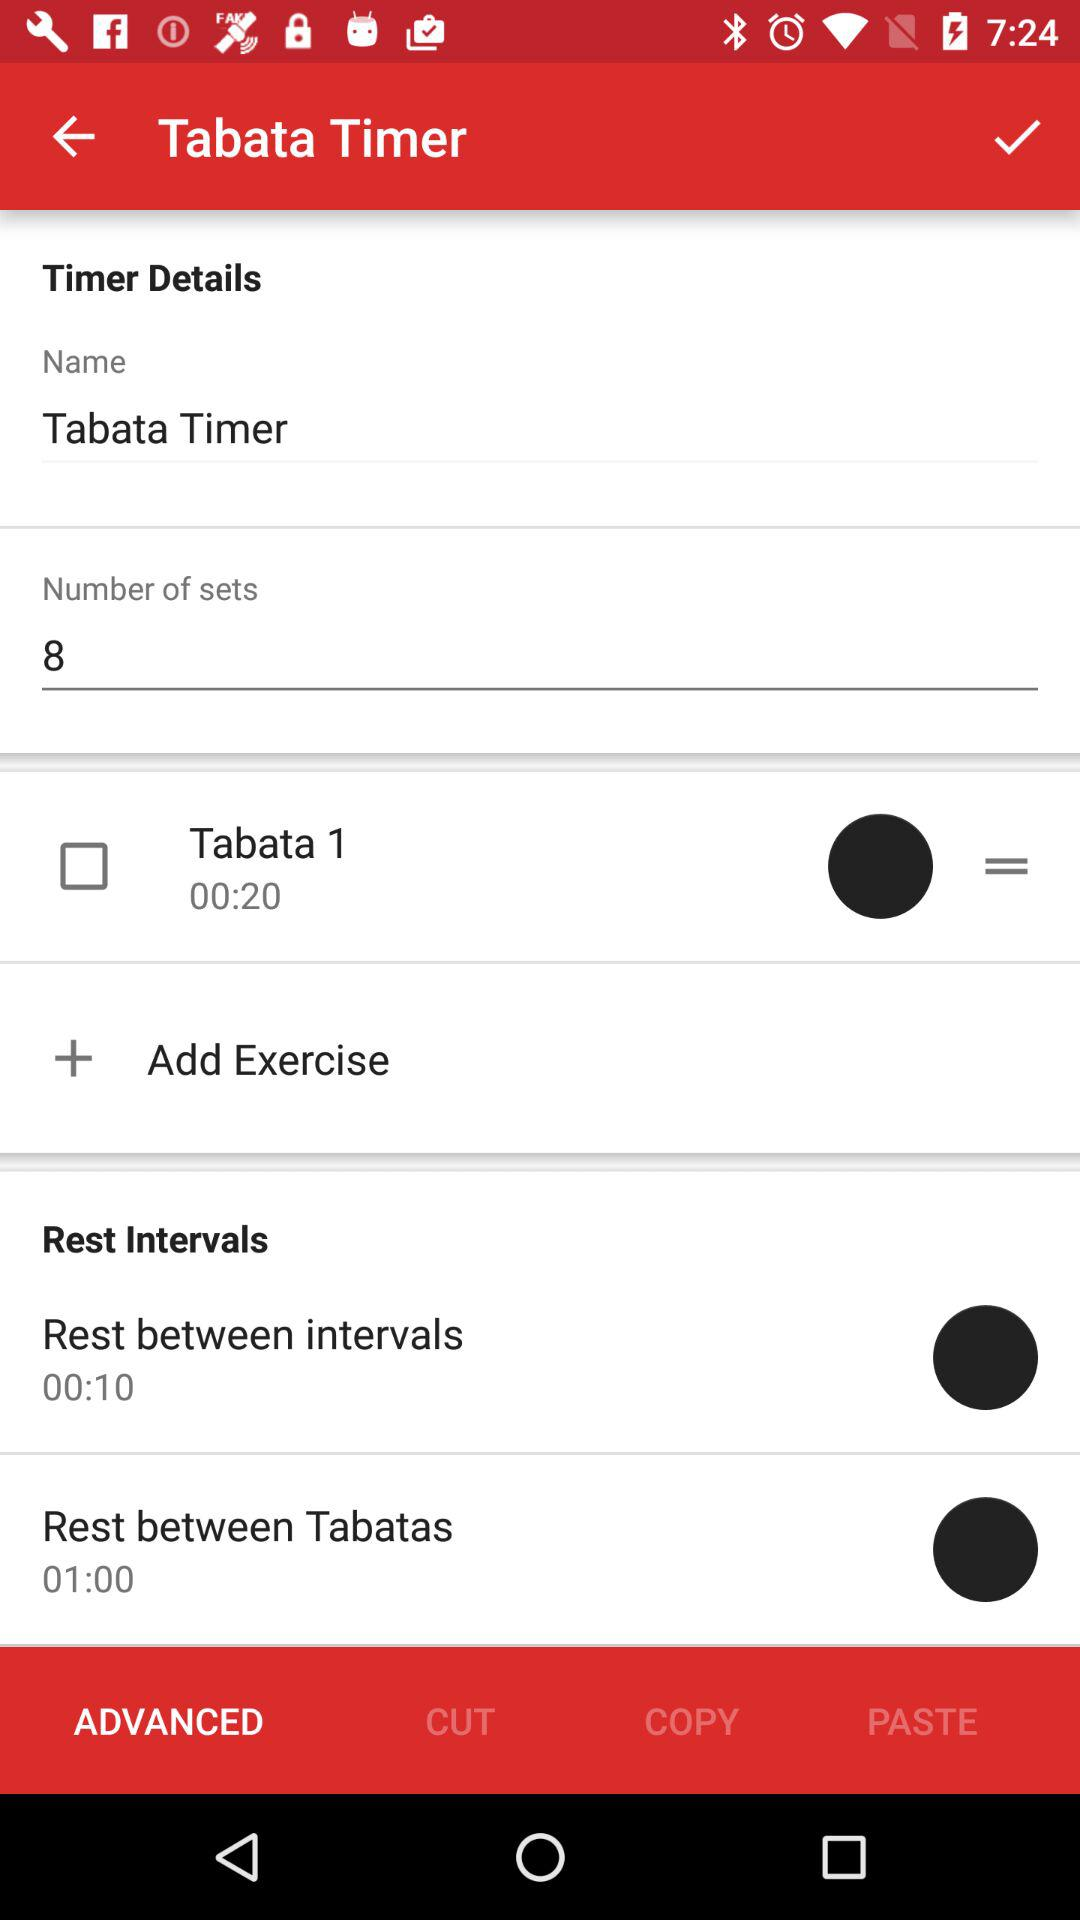What is the selected option? The selected option is "ADVANCED". 